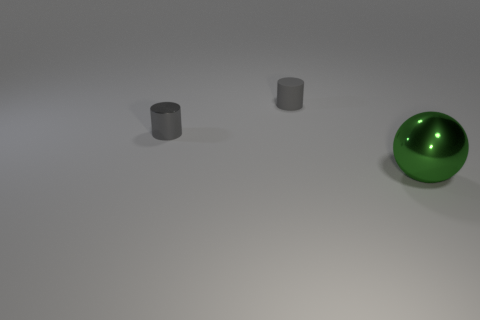Is there anything else that is the same shape as the green metal object? No, there isn’t. The green object is spherical, and the other objects in the image are cylindrical, which means they have different shapes. The sphere has a continuous surface without edges, whereas the cylinders have two flat faces and a curved surface. 